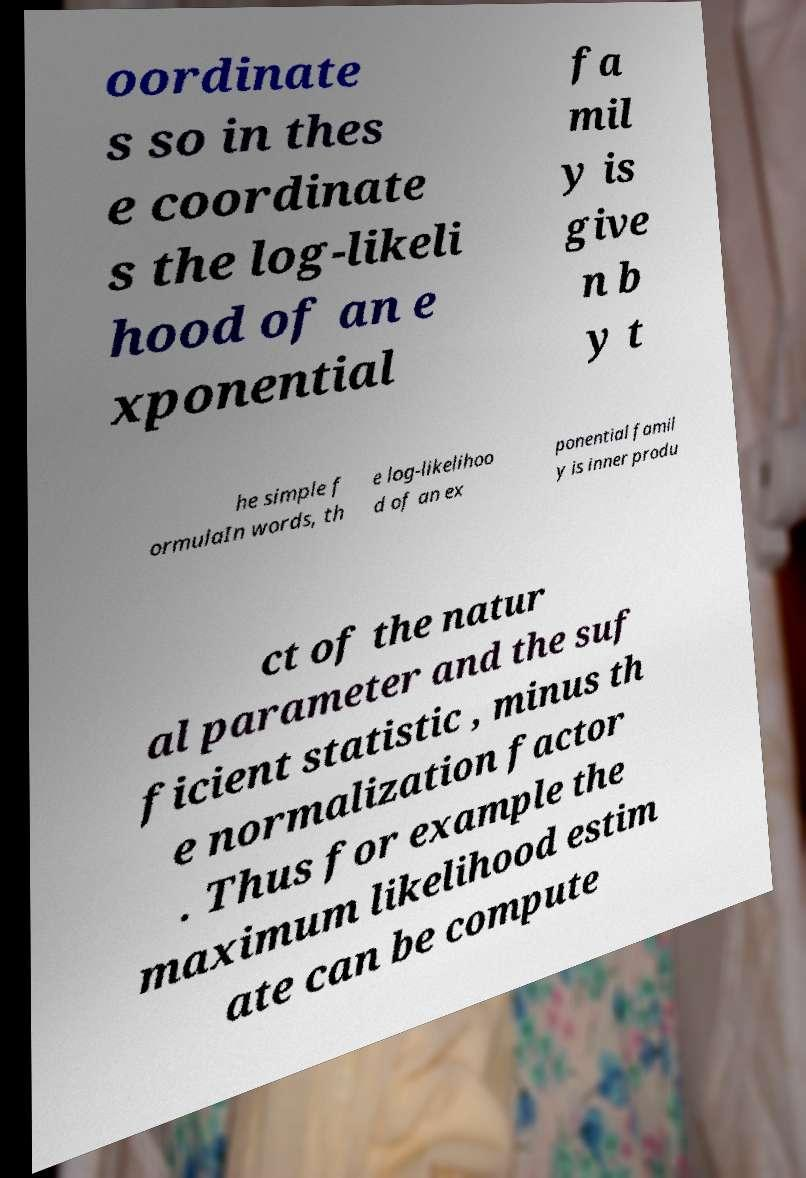Please identify and transcribe the text found in this image. oordinate s so in thes e coordinate s the log-likeli hood of an e xponential fa mil y is give n b y t he simple f ormulaIn words, th e log-likelihoo d of an ex ponential famil y is inner produ ct of the natur al parameter and the suf ficient statistic , minus th e normalization factor . Thus for example the maximum likelihood estim ate can be compute 